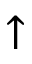<formula> <loc_0><loc_0><loc_500><loc_500>\uparrow</formula> 